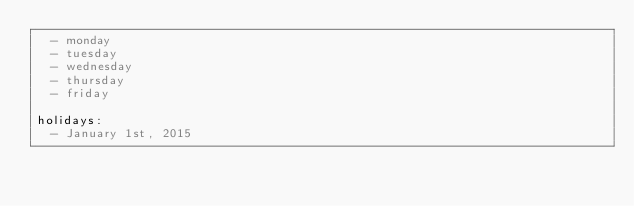<code> <loc_0><loc_0><loc_500><loc_500><_YAML_>  - monday
  - tuesday
  - wednesday
  - thursday
  - friday

holidays:
  - January 1st, 2015
</code> 